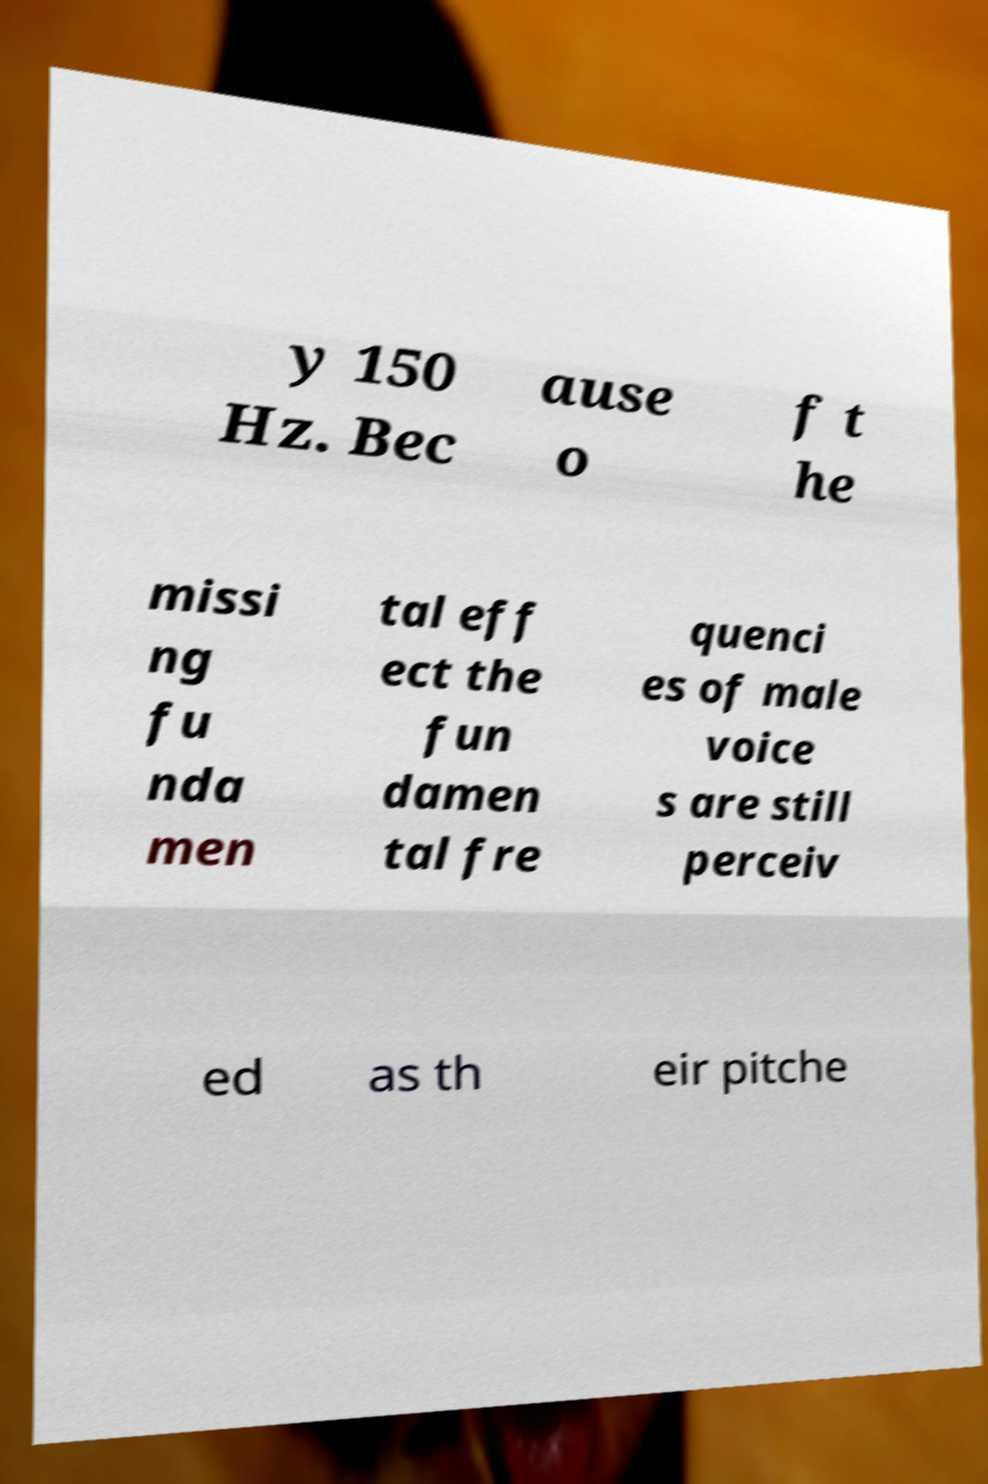There's text embedded in this image that I need extracted. Can you transcribe it verbatim? y 150 Hz. Bec ause o f t he missi ng fu nda men tal eff ect the fun damen tal fre quenci es of male voice s are still perceiv ed as th eir pitche 